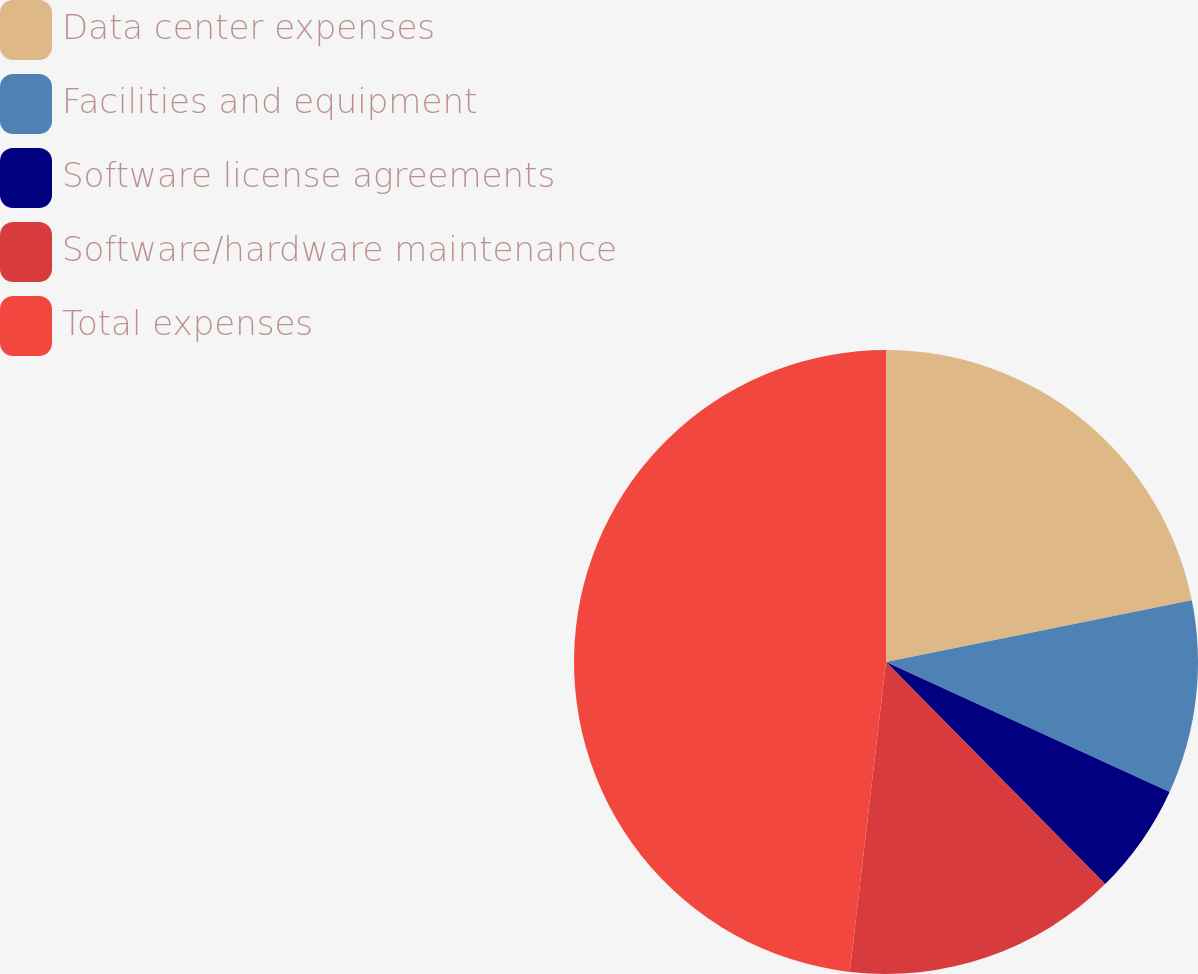<chart> <loc_0><loc_0><loc_500><loc_500><pie_chart><fcel>Data center expenses<fcel>Facilities and equipment<fcel>Software license agreements<fcel>Software/hardware maintenance<fcel>Total expenses<nl><fcel>21.83%<fcel>10.01%<fcel>5.77%<fcel>14.25%<fcel>48.15%<nl></chart> 